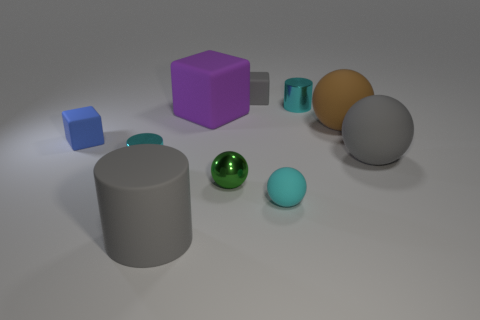Subtract all blocks. How many objects are left? 7 Subtract 1 blue cubes. How many objects are left? 9 Subtract all small cyan metallic balls. Subtract all tiny green things. How many objects are left? 9 Add 8 purple things. How many purple things are left? 9 Add 5 tiny green rubber objects. How many tiny green rubber objects exist? 5 